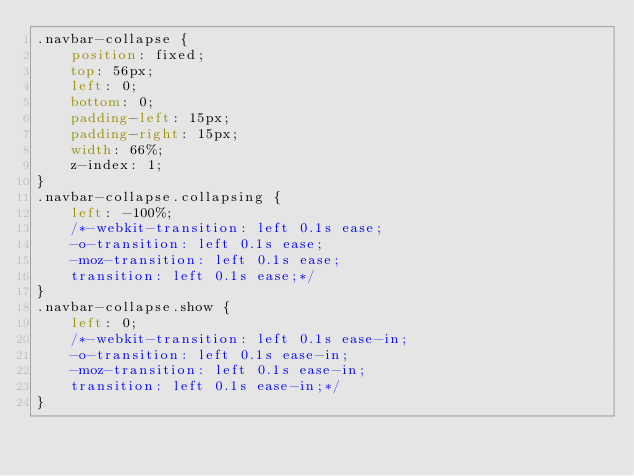<code> <loc_0><loc_0><loc_500><loc_500><_CSS_>.navbar-collapse {
    position: fixed;
    top: 56px;
    left: 0;
    bottom: 0;
    padding-left: 15px;
    padding-right: 15px;
    width: 66%;
    z-index: 1;
}
.navbar-collapse.collapsing {
    left: -100%;
    /*-webkit-transition: left 0.1s ease;
    -o-transition: left 0.1s ease;
    -moz-transition: left 0.1s ease;
    transition: left 0.1s ease;*/
}
.navbar-collapse.show {
    left: 0;
    /*-webkit-transition: left 0.1s ease-in;
    -o-transition: left 0.1s ease-in;
    -moz-transition: left 0.1s ease-in;
    transition: left 0.1s ease-in;*/
}</code> 